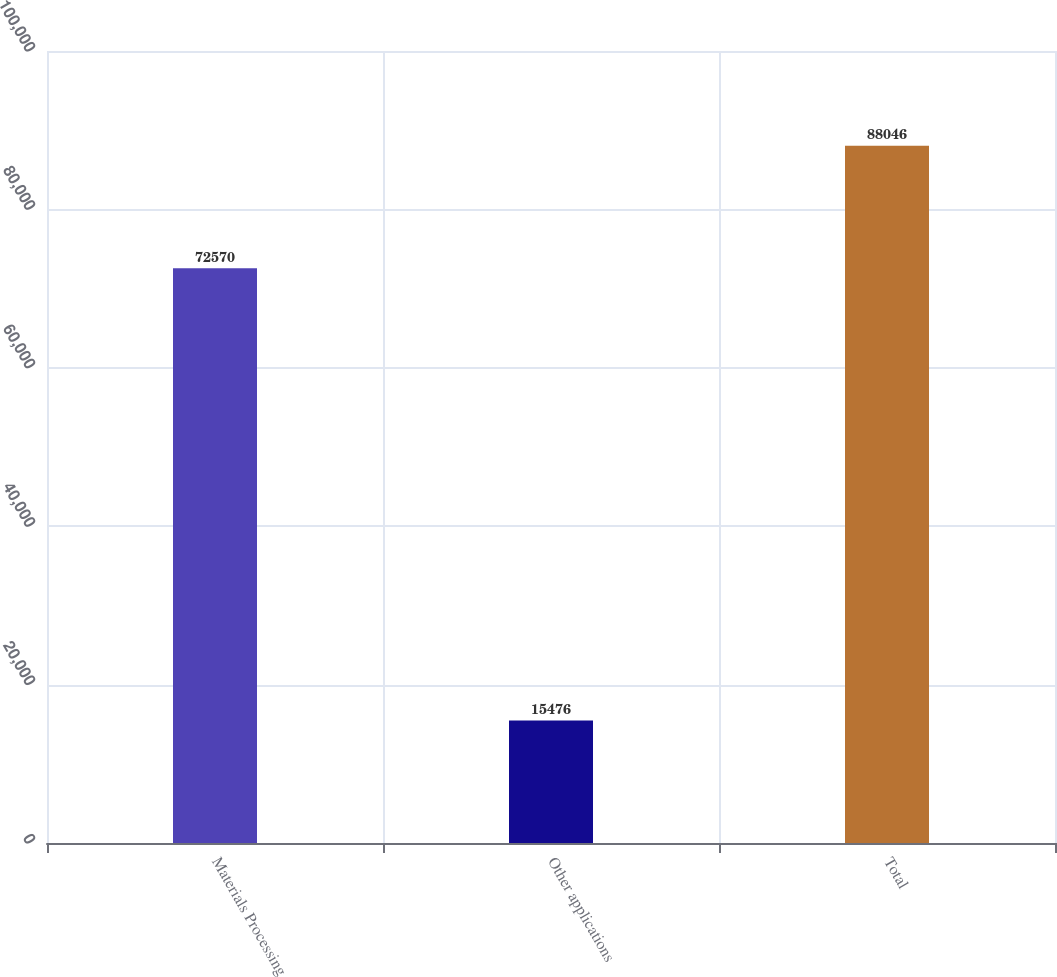<chart> <loc_0><loc_0><loc_500><loc_500><bar_chart><fcel>Materials Processing<fcel>Other applications<fcel>Total<nl><fcel>72570<fcel>15476<fcel>88046<nl></chart> 